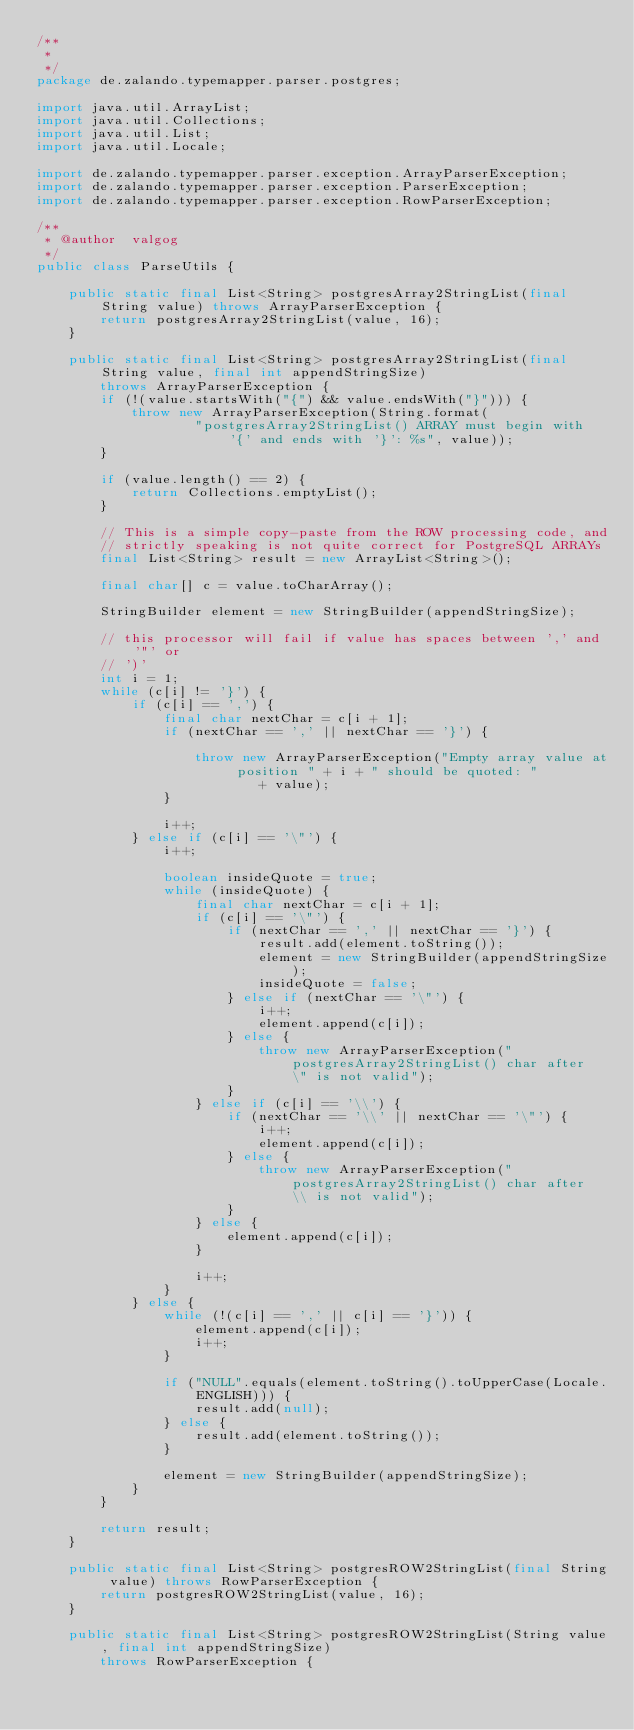Convert code to text. <code><loc_0><loc_0><loc_500><loc_500><_Java_>/**
 *
 */
package de.zalando.typemapper.parser.postgres;

import java.util.ArrayList;
import java.util.Collections;
import java.util.List;
import java.util.Locale;

import de.zalando.typemapper.parser.exception.ArrayParserException;
import de.zalando.typemapper.parser.exception.ParserException;
import de.zalando.typemapper.parser.exception.RowParserException;

/**
 * @author  valgog
 */
public class ParseUtils {

    public static final List<String> postgresArray2StringList(final String value) throws ArrayParserException {
        return postgresArray2StringList(value, 16);
    }

    public static final List<String> postgresArray2StringList(final String value, final int appendStringSize)
        throws ArrayParserException {
        if (!(value.startsWith("{") && value.endsWith("}"))) {
            throw new ArrayParserException(String.format(
                    "postgresArray2StringList() ARRAY must begin with '{' and ends with '}': %s", value));
        }

        if (value.length() == 2) {
            return Collections.emptyList();
        }

        // This is a simple copy-paste from the ROW processing code, and
        // strictly speaking is not quite correct for PostgreSQL ARRAYs
        final List<String> result = new ArrayList<String>();

        final char[] c = value.toCharArray();

        StringBuilder element = new StringBuilder(appendStringSize);

        // this processor will fail if value has spaces between ',' and '"' or
        // ')'
        int i = 1;
        while (c[i] != '}') {
            if (c[i] == ',') {
                final char nextChar = c[i + 1];
                if (nextChar == ',' || nextChar == '}') {

                    throw new ArrayParserException("Empty array value at position " + i + " should be quoted: "
                            + value);
                }

                i++;
            } else if (c[i] == '\"') {
                i++;

                boolean insideQuote = true;
                while (insideQuote) {
                    final char nextChar = c[i + 1];
                    if (c[i] == '\"') {
                        if (nextChar == ',' || nextChar == '}') {
                            result.add(element.toString());
                            element = new StringBuilder(appendStringSize);
                            insideQuote = false;
                        } else if (nextChar == '\"') {
                            i++;
                            element.append(c[i]);
                        } else {
                            throw new ArrayParserException("postgresArray2StringList() char after \" is not valid");
                        }
                    } else if (c[i] == '\\') {
                        if (nextChar == '\\' || nextChar == '\"') {
                            i++;
                            element.append(c[i]);
                        } else {
                            throw new ArrayParserException("postgresArray2StringList() char after \\ is not valid");
                        }
                    } else {
                        element.append(c[i]);
                    }

                    i++;
                }
            } else {
                while (!(c[i] == ',' || c[i] == '}')) {
                    element.append(c[i]);
                    i++;
                }

                if ("NULL".equals(element.toString().toUpperCase(Locale.ENGLISH))) {
                    result.add(null);
                } else {
                    result.add(element.toString());
                }

                element = new StringBuilder(appendStringSize);
            }
        }

        return result;
    }

    public static final List<String> postgresROW2StringList(final String value) throws RowParserException {
        return postgresROW2StringList(value, 16);
    }

    public static final List<String> postgresROW2StringList(String value, final int appendStringSize)
        throws RowParserException {</code> 